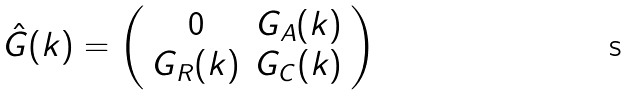<formula> <loc_0><loc_0><loc_500><loc_500>\hat { G } ( k ) = \left ( \begin{array} { c c } 0 & G _ { A } ( k ) \\ G _ { R } ( k ) & G _ { C } ( k ) \end{array} \right )</formula> 